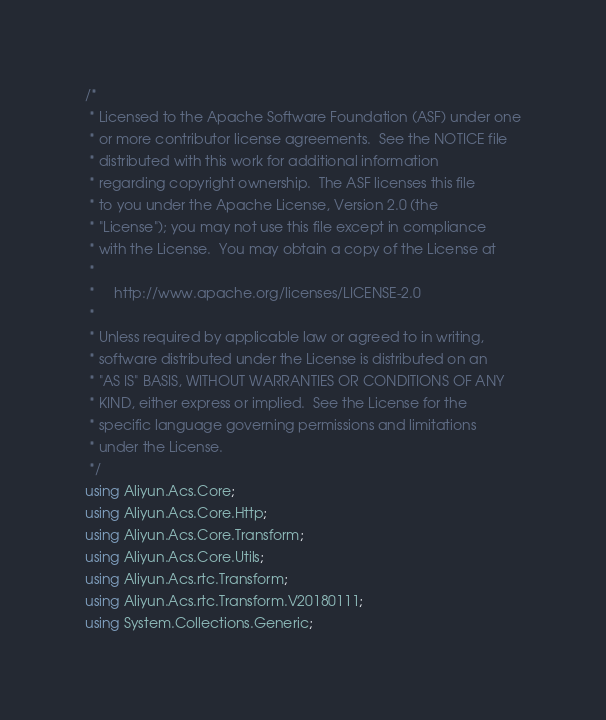Convert code to text. <code><loc_0><loc_0><loc_500><loc_500><_C#_>/*
 * Licensed to the Apache Software Foundation (ASF) under one
 * or more contributor license agreements.  See the NOTICE file
 * distributed with this work for additional information
 * regarding copyright ownership.  The ASF licenses this file
 * to you under the Apache License, Version 2.0 (the
 * "License"); you may not use this file except in compliance
 * with the License.  You may obtain a copy of the License at
 *
 *     http://www.apache.org/licenses/LICENSE-2.0
 *
 * Unless required by applicable law or agreed to in writing,
 * software distributed under the License is distributed on an
 * "AS IS" BASIS, WITHOUT WARRANTIES OR CONDITIONS OF ANY
 * KIND, either express or implied.  See the License for the
 * specific language governing permissions and limitations
 * under the License.
 */
using Aliyun.Acs.Core;
using Aliyun.Acs.Core.Http;
using Aliyun.Acs.Core.Transform;
using Aliyun.Acs.Core.Utils;
using Aliyun.Acs.rtc.Transform;
using Aliyun.Acs.rtc.Transform.V20180111;
using System.Collections.Generic;
</code> 